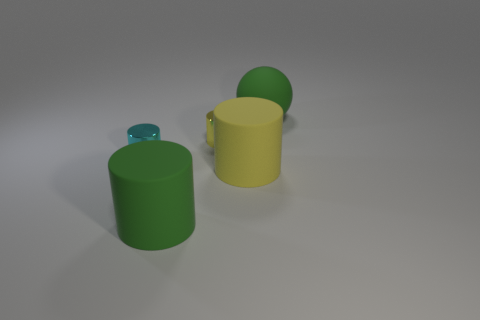How many yellow cylinders must be subtracted to get 1 yellow cylinders? 1 Add 3 big spheres. How many objects exist? 8 Subtract all small yellow cylinders. How many cylinders are left? 3 Subtract all green cylinders. How many cylinders are left? 3 Subtract all cyan spheres. How many yellow cylinders are left? 2 Subtract 3 cylinders. How many cylinders are left? 1 Subtract all cylinders. How many objects are left? 1 Subtract 0 green blocks. How many objects are left? 5 Subtract all blue balls. Subtract all blue cylinders. How many balls are left? 1 Subtract all small cyan metallic cylinders. Subtract all tiny yellow objects. How many objects are left? 3 